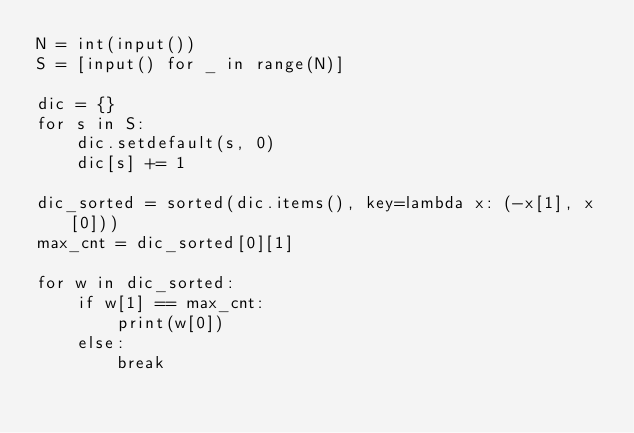<code> <loc_0><loc_0><loc_500><loc_500><_Python_>N = int(input())
S = [input() for _ in range(N)]

dic = {}
for s in S:
    dic.setdefault(s, 0)
    dic[s] += 1

dic_sorted = sorted(dic.items(), key=lambda x: (-x[1], x[0]))
max_cnt = dic_sorted[0][1]

for w in dic_sorted:
    if w[1] == max_cnt:
        print(w[0])
    else:
        break
</code> 